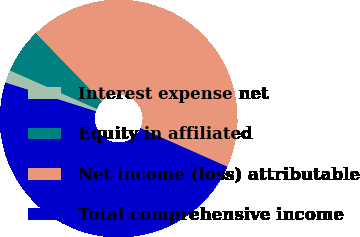Convert chart. <chart><loc_0><loc_0><loc_500><loc_500><pie_chart><fcel>Interest expense net<fcel>Equity in affiliated<fcel>Net income (loss) attributable<fcel>Total comprehensive income<nl><fcel>1.75%<fcel>6.11%<fcel>43.89%<fcel>48.25%<nl></chart> 